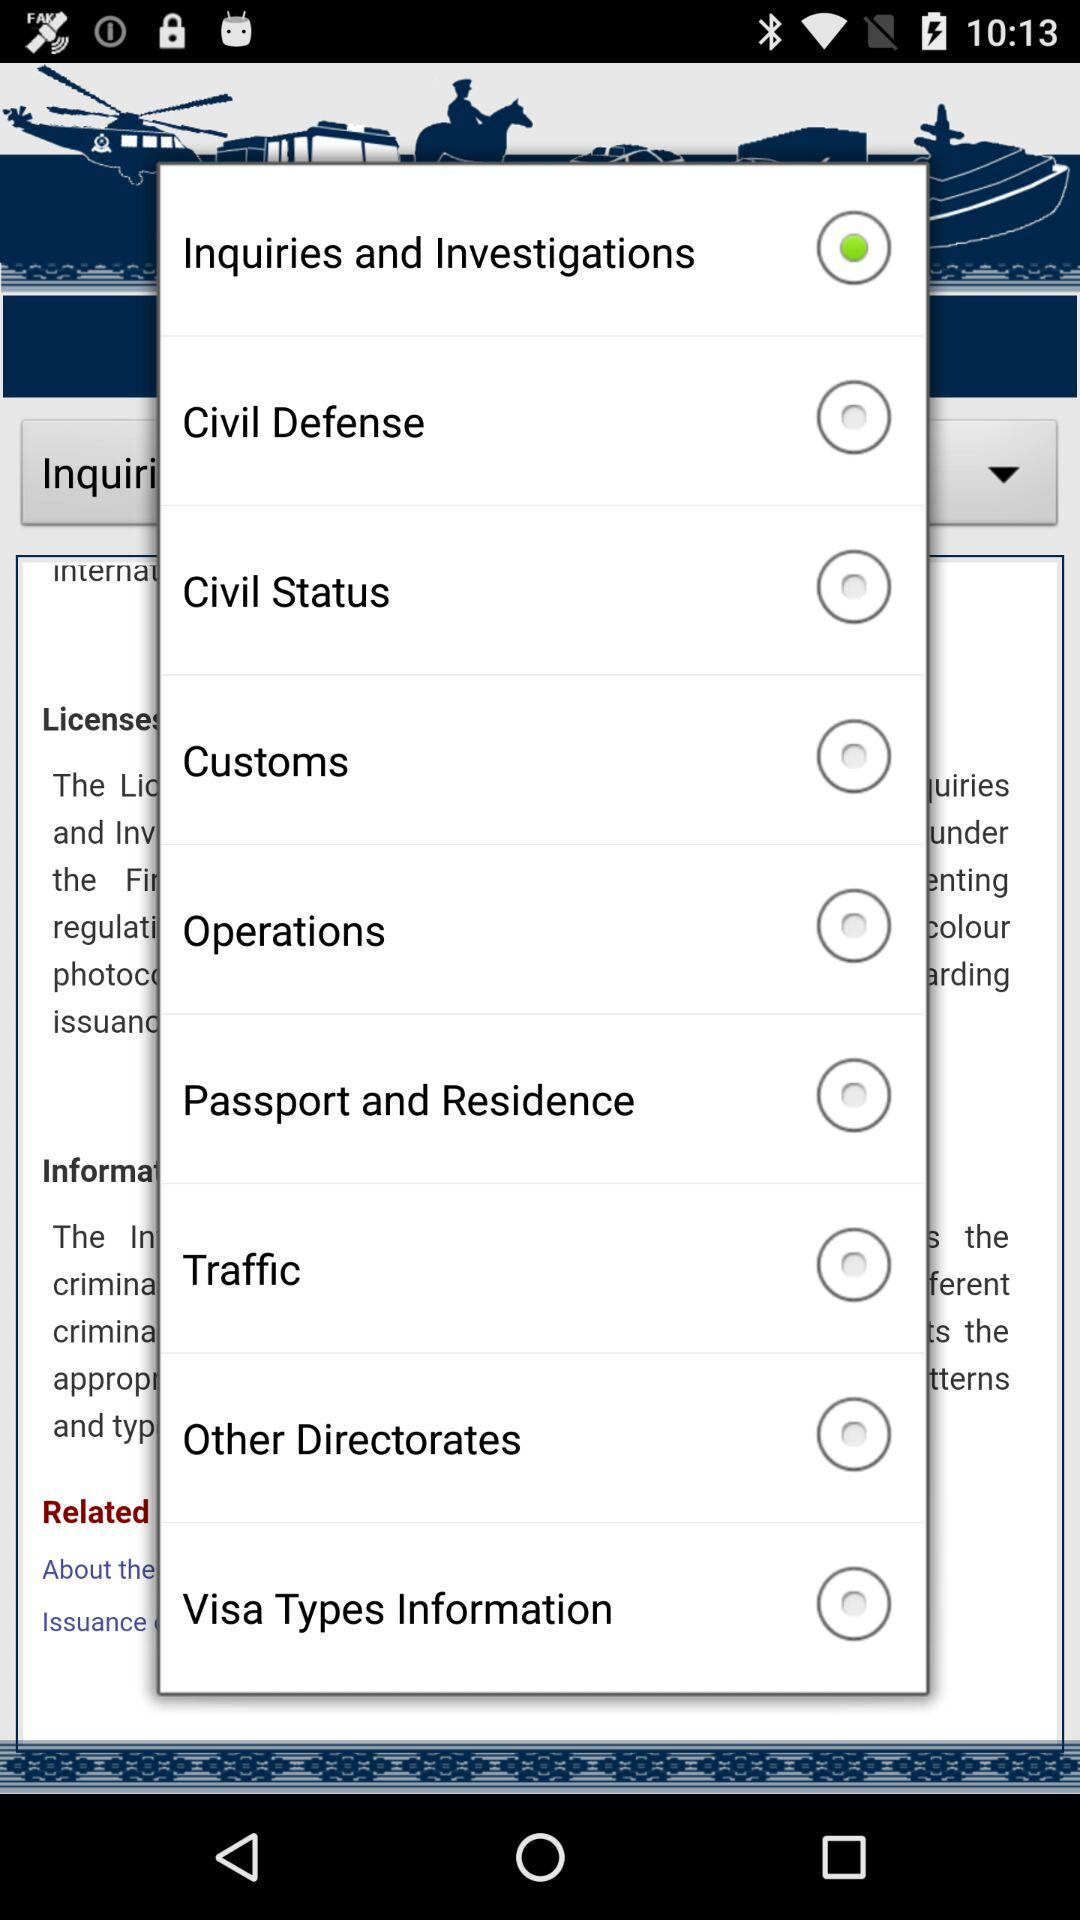What is the status of the "Civil Defense"? The status is "off". 